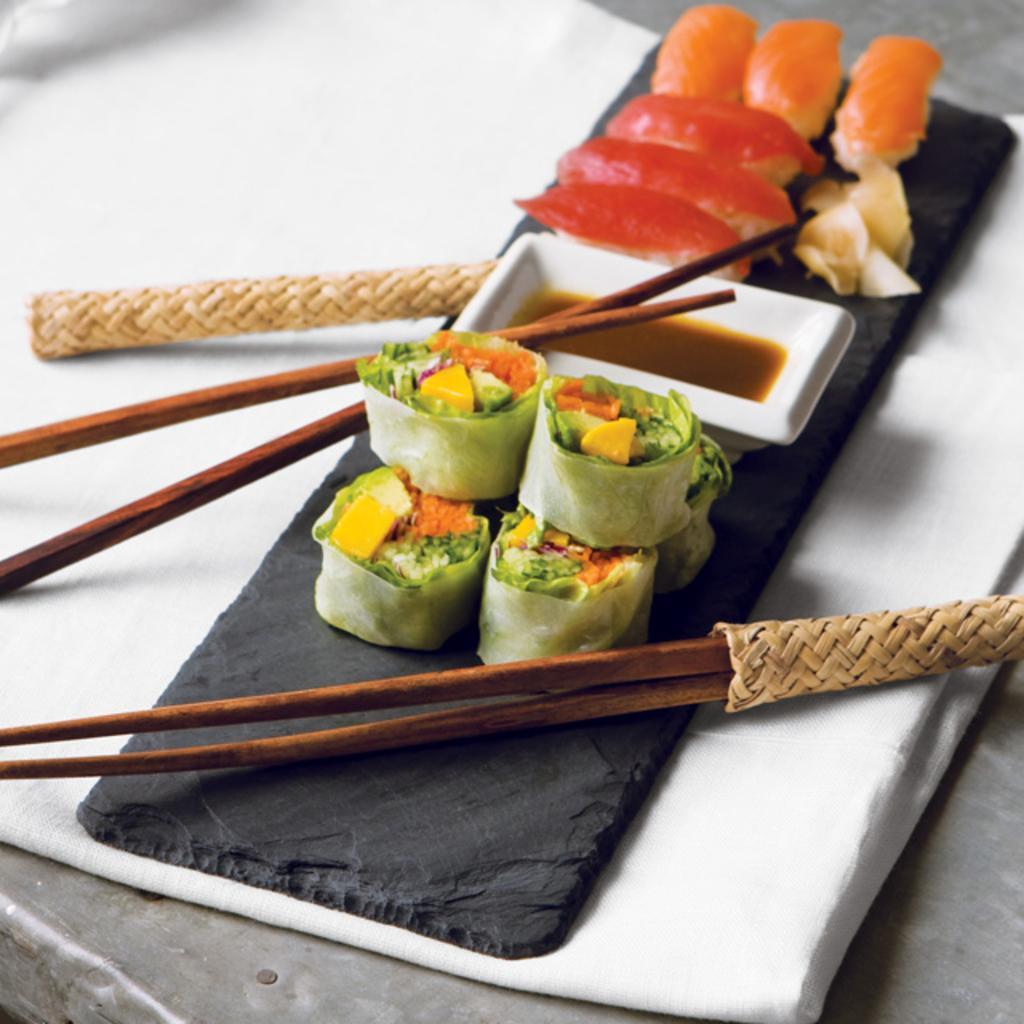Could you give a brief overview of what you see in this image? There is a table. On the table there is a white cloth. Above that there is a back cloth. On that there are chopsticks, food items, and a bowl. 